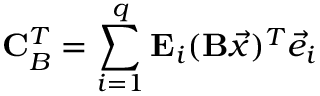Convert formula to latex. <formula><loc_0><loc_0><loc_500><loc_500>C _ { B } ^ { T } = \sum _ { i = 1 } ^ { q } E _ { i } ( B \vec { x } ) ^ { T } \vec { e } _ { i }</formula> 